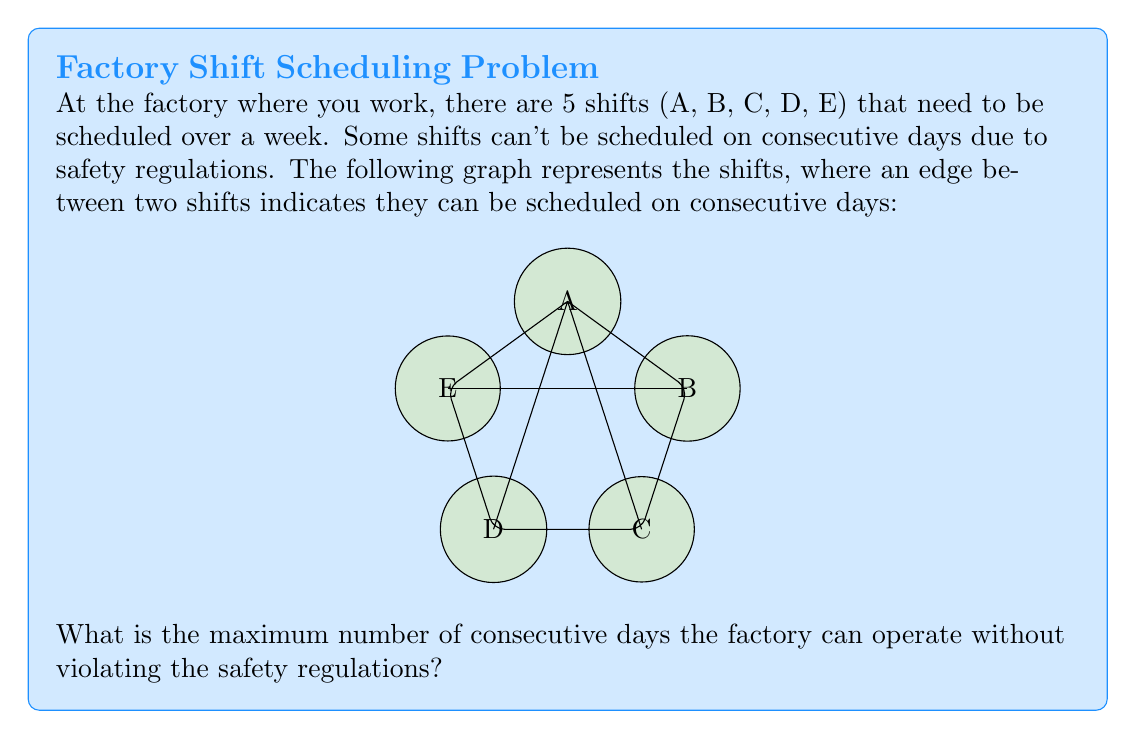Can you solve this math problem? To solve this problem, we need to find the longest path in the given graph. This path represents the maximum number of shifts that can be scheduled consecutively without violating the safety regulations.

Step 1: Identify all possible paths in the graph.
- A-B-C-D-E
- A-B-E-D-C
- A-C-B-E-D
- A-D-E-B-C
- E-A-B-C-D
- E-A-D-C-B

Step 2: Count the number of edges in each path.
All paths have 4 edges, which means they connect 5 vertices (shifts).

Step 3: Interpret the result.
The longest path in the graph has 4 edges, connecting 5 vertices. This means we can schedule 5 shifts consecutively without violating the safety regulations.

Step 4: Translate to days of operation.
Since each shift represents one day of operation, the maximum number of consecutive days the factory can operate is 5.
Answer: 5 days 